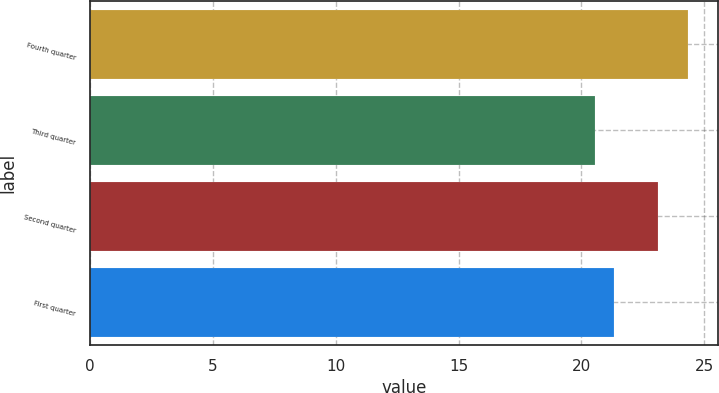Convert chart. <chart><loc_0><loc_0><loc_500><loc_500><bar_chart><fcel>Fourth quarter<fcel>Third quarter<fcel>Second quarter<fcel>First quarter<nl><fcel>24.34<fcel>20.54<fcel>23.11<fcel>21.33<nl></chart> 